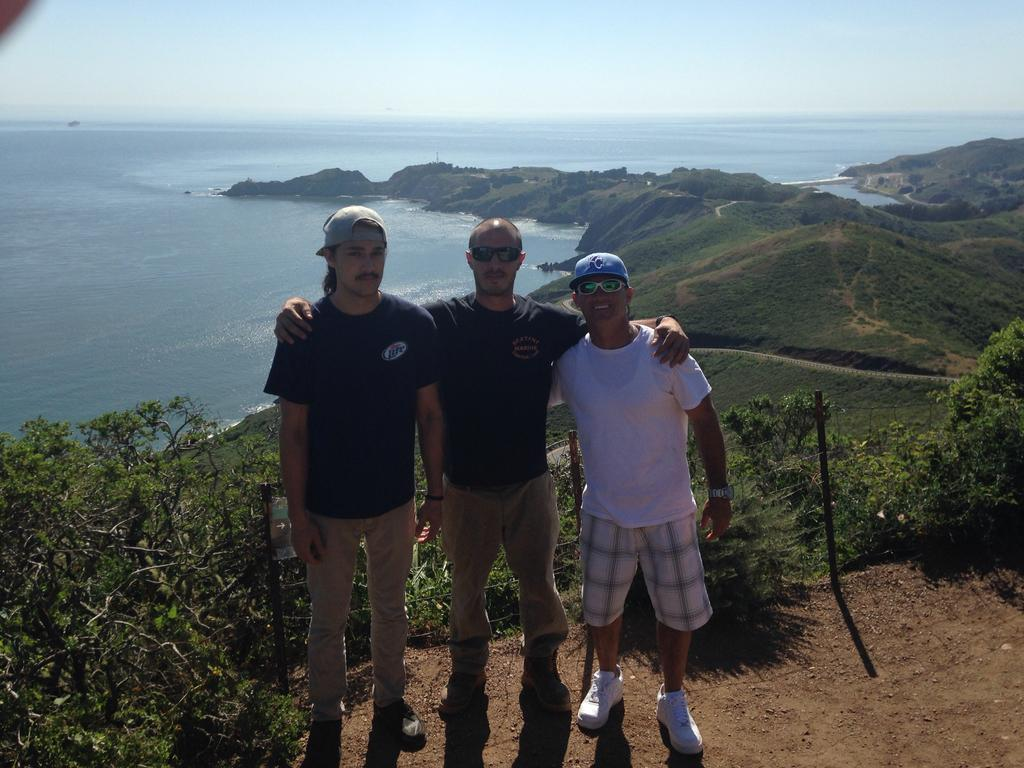How many men are present in the image? There are three men standing on the ground in the image. What type of terrain is visible in the image? There is grass, water, and rocks visible in the image. What structures can be seen in the image? There is a fence in the image. What natural elements are present in the image? There are trees in the image. What is visible in the background of the image? The sky is visible in the background of the image. How many chairs are visible in the image? There are no chairs present in the image. Can you see a plane flying in the sky in the image? There is no plane visible in the sky in the image. 